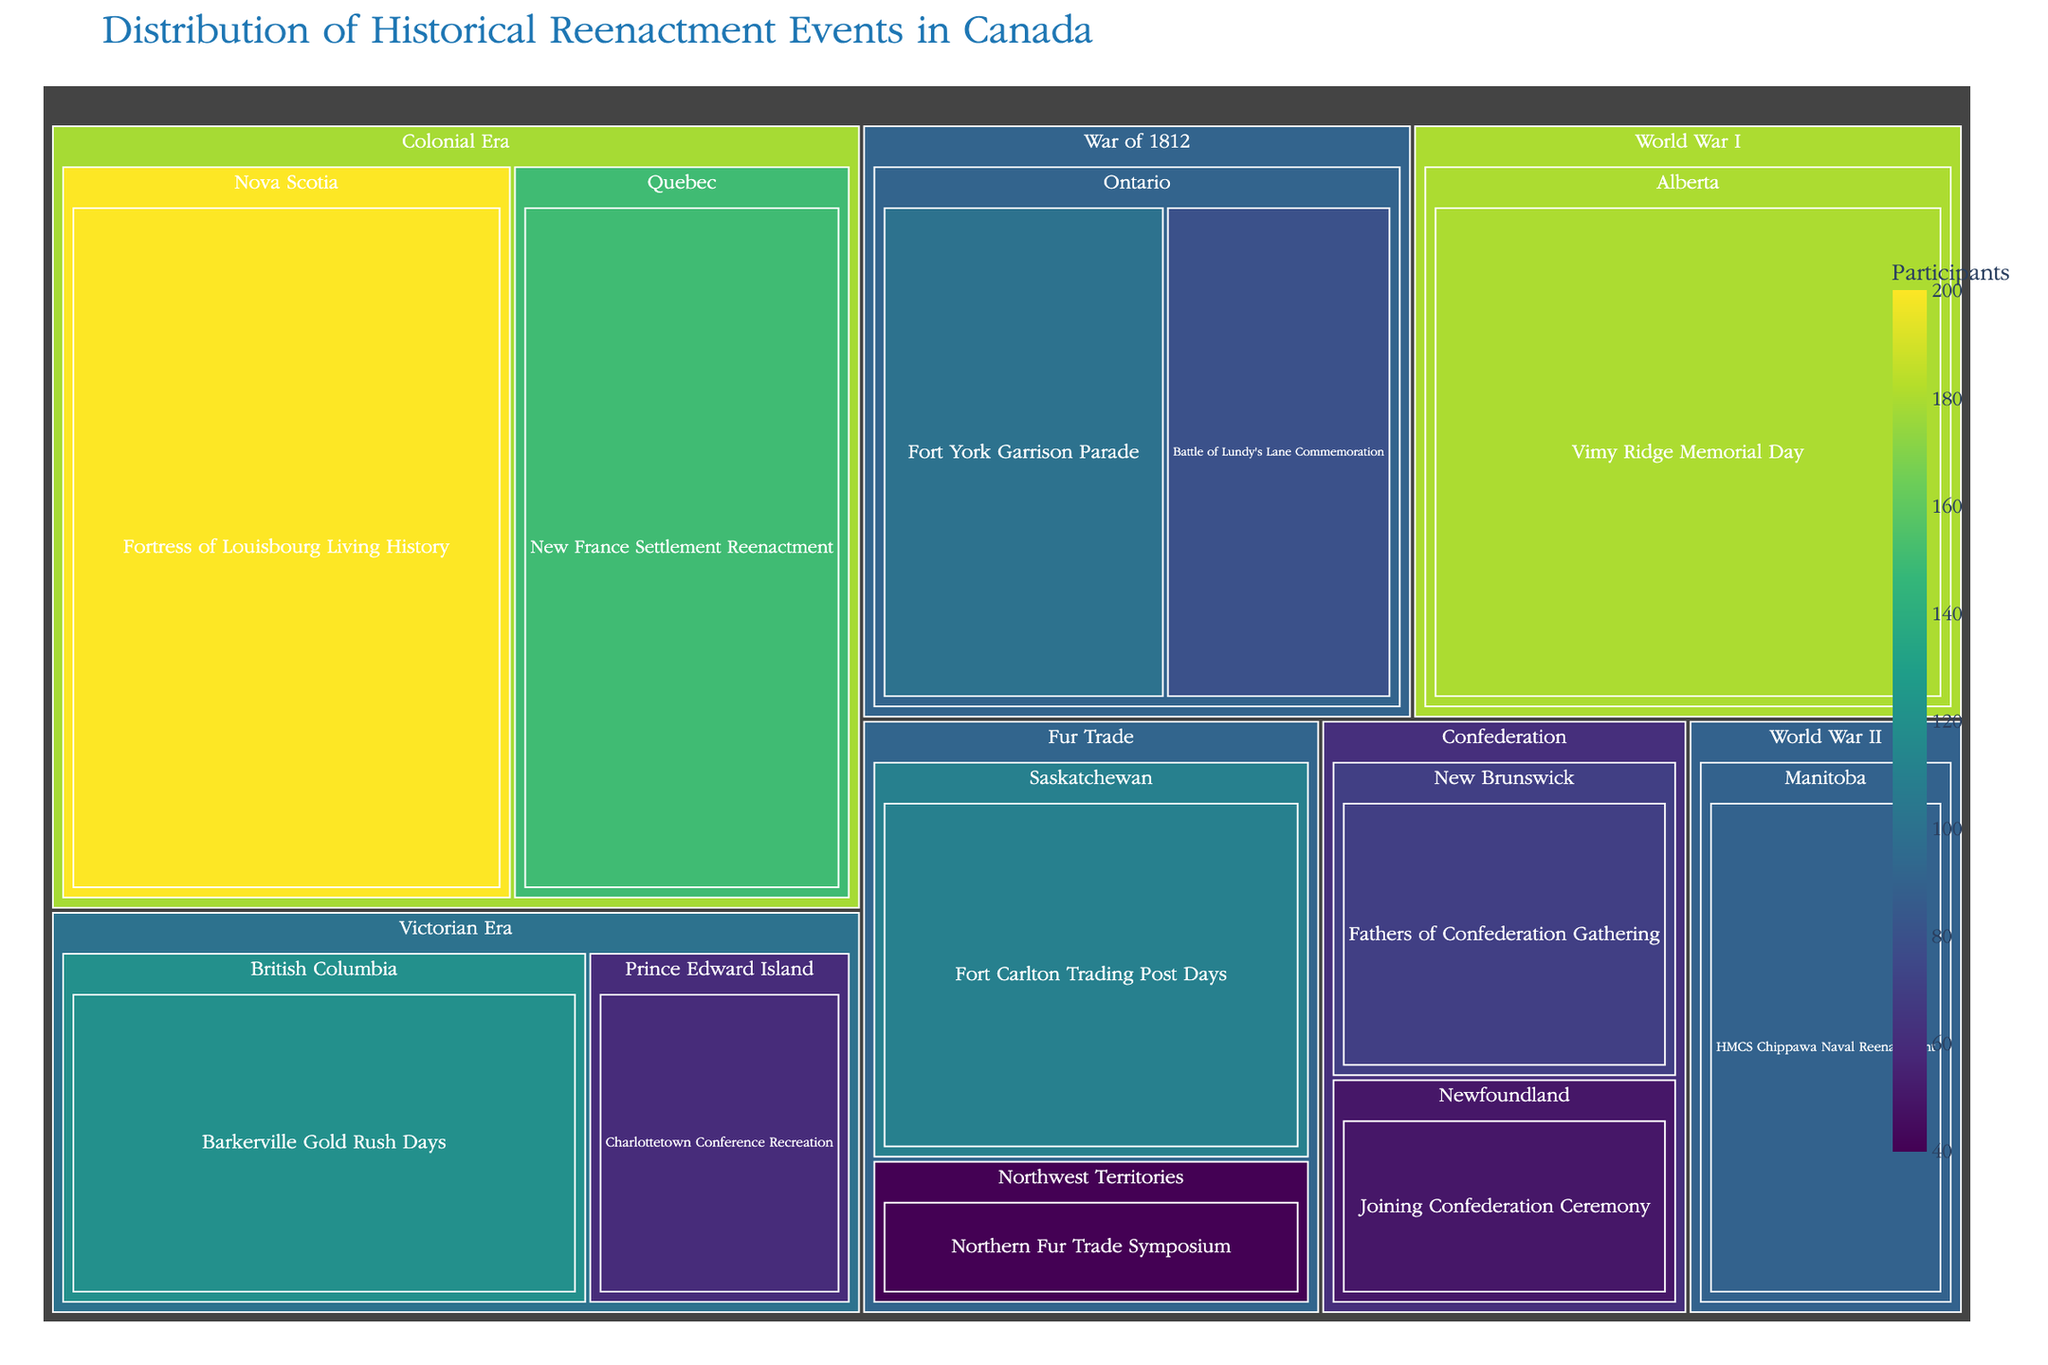What is the title of the treemap? The title of a figure is typically displayed prominently at the top, providing the main subject or insight of the visual. By looking at the figure, you can find the title "Distribution of Historical Reenactment Events in Canada" displayed at the top.
Answer: Distribution of Historical Reenactment Events in Canada Which event has the highest number of participants? On the treemap, each event is represented by a rectangle. The size of the rectangles is proportional to the number of participants, and the largest rectangle represents the event with the most participants. In this case, the "Fortress of Louisbourg Living History" in the Colonial Era in Nova Scotia has 200 participants, which is the highest.
Answer: Fortress of Louisbourg Living History How many events are represented for the War of 1812? Each time period is a branch in the treemap, which further branches into provinces and events. By examining the "War of 1812" branch, you can see that there are two events listed: "Battle of Lundy's Lane Commemoration" in Ontario and "Fort York Garrison Parade" also in Ontario.
Answer: 2 Which province is represented by only one event? In the treemap, each province contains rectangles for each event. A quick scan reveals that Alberta and Manitoba each have only one event listed. Alberta has the "Vimy Ridge Memorial Day," and Manitoba has "HMCS Chippawa Naval Reenactment."
Answer: Alberta and Manitoba What is the sum of participants in events taking place in Ontario? The treemap shows two events in Ontario: "Battle of Lundy's Lane Commemoration" with 80 participants and "Fort York Garrison Parade" with 100 participants. Summing these up: 80 + 100 = 180 participants.
Answer: 180 Which time period has the highest total number of participants, and what is that total? To determine this, sum up the participants for all events within each time period and compare the totals. For example, the Colonial Era has 150 (New France Settlement Reenactment) + 200 (Fortress of Louisbourg Living History) = 350 participants. Calculating for each period reveals that the Colonial Era, with 350 participants, has the highest total.
Answer: Colonial Era, 350 Are there any events in the Northwest Territories, and if so, which time period do they belong to and how many participants are involved? The treemap includes a branch for the Northwest Territories, which includes the event "Northern Fur Trade Symposium." This information shows that the event belongs to the "Fur Trade" period and has 40 participants.
Answer: Yes, Fur Trade, 40 participants Which event in the Victorian Era has the least number of participants? The treemap shows the Victorian Era with two events: "Barkerville Gold Rush Days" in British Columbia with 120 participants and "Charlottetown Conference Recreation" in Prince Edward Island with 60 participants. The Charlottetown Conference Recreation has the least participants.
Answer: Charlottetown Conference Recreation What is the average number of participants for events in the Colonial Era? The Colonial Era has two events: "New France Settlement Reenactment" with 150 participants and "Fortress of Louisbourg Living History" with 200 participants. The average is calculated as (150 + 200) / 2 = 175 participants.
Answer: 175 participants Which event(s) has the closest number of participants to the Vimy Ridge Memorial Day in Alberta, and how many participants are there in those events? The Vimy Ridge Memorial Day in Alberta has 180 participants. By looking at the treemap, an event with a close number of participants is "New France Settlement Reenactment" in Quebec, with 150 participants. These are the closest in participant count.
Answer: New France Settlement Reenactment, 150 participants 